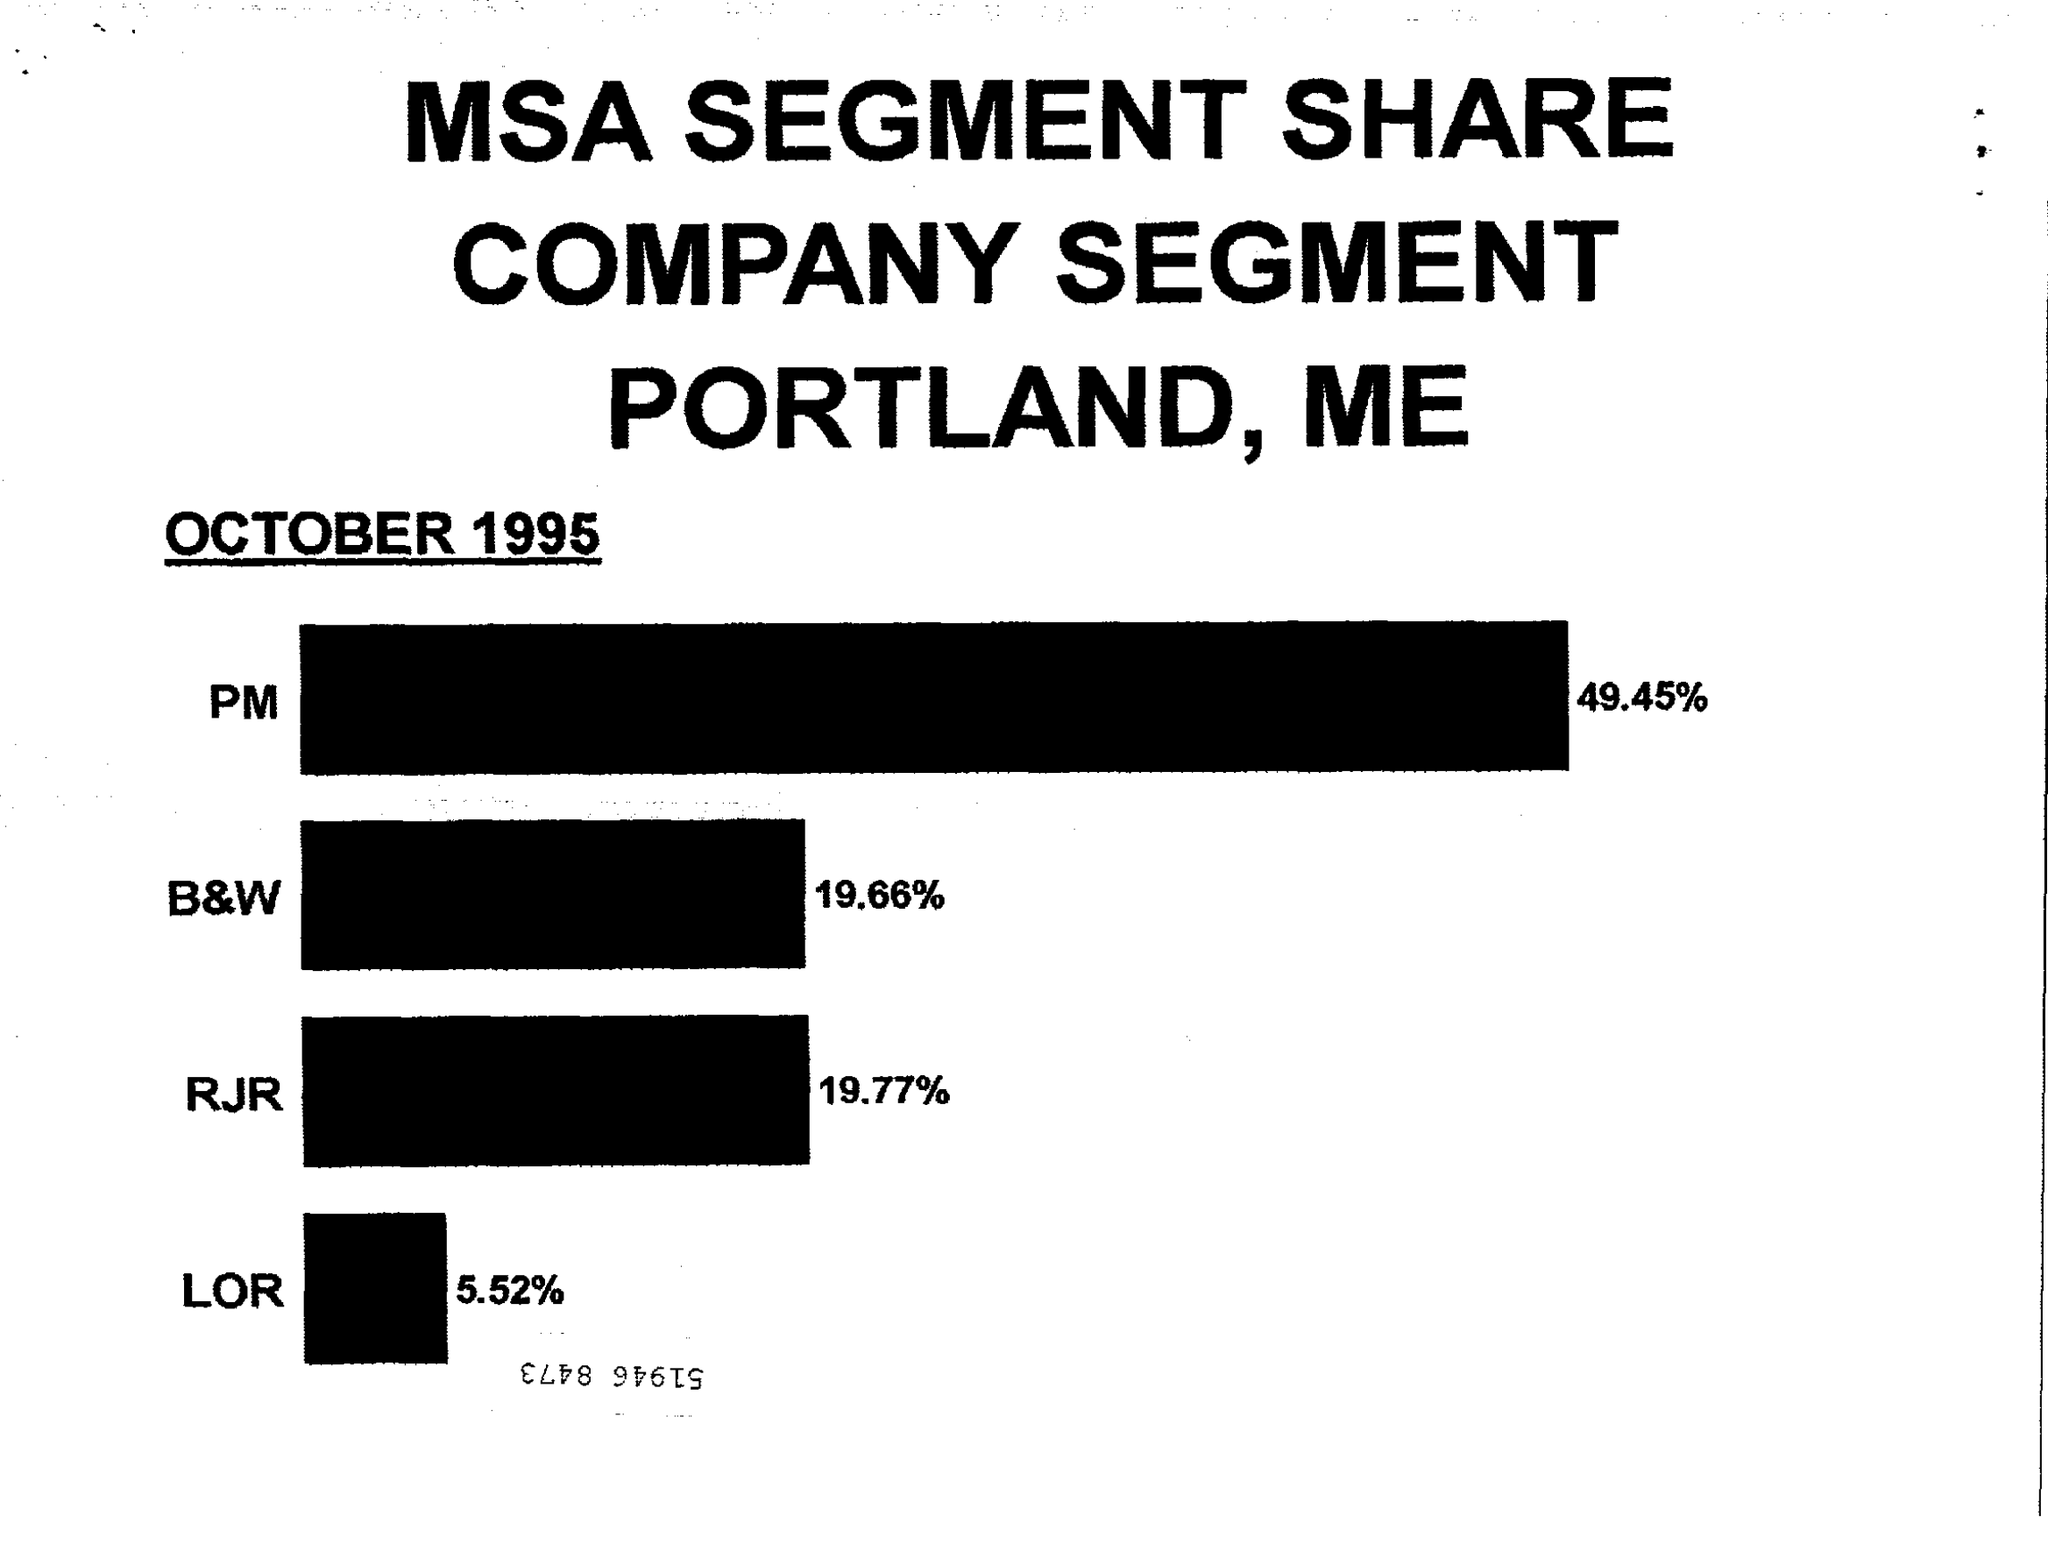When was the MSA SEGMENT SHARE dated?
Provide a short and direct response. October 1995. What is the % of PM?
Provide a short and direct response. 49.45. 